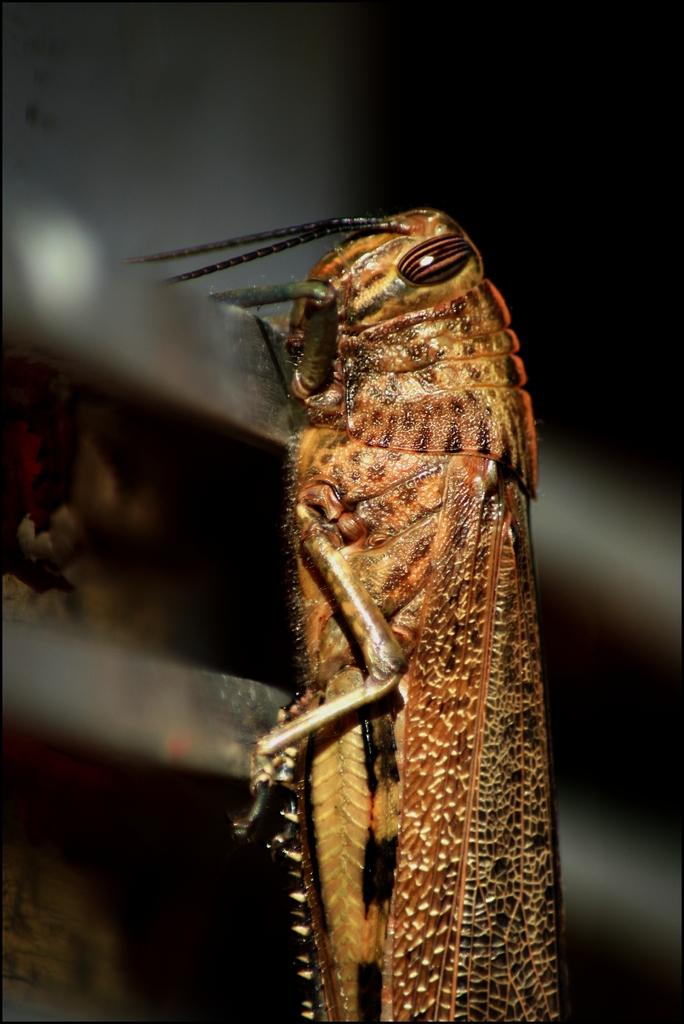What type of creature can be seen in the image? There is an insect in the image. What is the color of the insect? The insect is brown in color. What type of woolen clothing is the insect wearing in the image? There is no woolen clothing present in the image, as the insect is not wearing any clothing. 